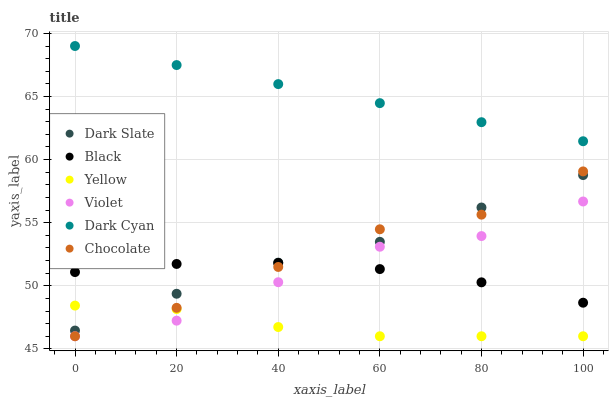Does Yellow have the minimum area under the curve?
Answer yes or no. Yes. Does Dark Cyan have the maximum area under the curve?
Answer yes or no. Yes. Does Chocolate have the minimum area under the curve?
Answer yes or no. No. Does Chocolate have the maximum area under the curve?
Answer yes or no. No. Is Dark Cyan the smoothest?
Answer yes or no. Yes. Is Violet the roughest?
Answer yes or no. Yes. Is Chocolate the smoothest?
Answer yes or no. No. Is Chocolate the roughest?
Answer yes or no. No. Does Yellow have the lowest value?
Answer yes or no. Yes. Does Dark Slate have the lowest value?
Answer yes or no. No. Does Dark Cyan have the highest value?
Answer yes or no. Yes. Does Chocolate have the highest value?
Answer yes or no. No. Is Black less than Dark Cyan?
Answer yes or no. Yes. Is Dark Cyan greater than Yellow?
Answer yes or no. Yes. Does Dark Slate intersect Black?
Answer yes or no. Yes. Is Dark Slate less than Black?
Answer yes or no. No. Is Dark Slate greater than Black?
Answer yes or no. No. Does Black intersect Dark Cyan?
Answer yes or no. No. 